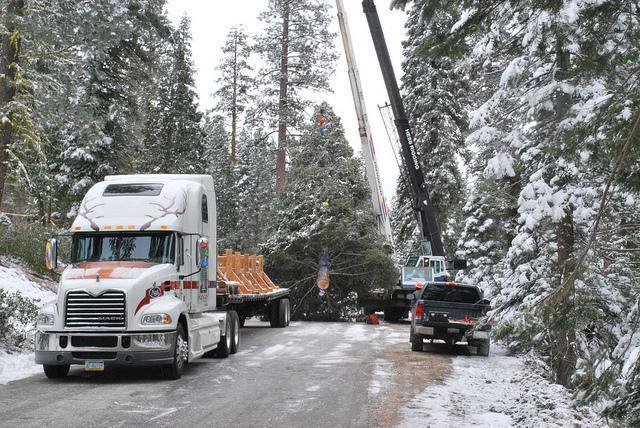How many cars are visible?
Give a very brief answer. 1. How many trucks are there?
Give a very brief answer. 2. 